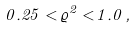Convert formula to latex. <formula><loc_0><loc_0><loc_500><loc_500>0 . 2 5 < \varrho ^ { 2 } < 1 . 0 \, ,</formula> 